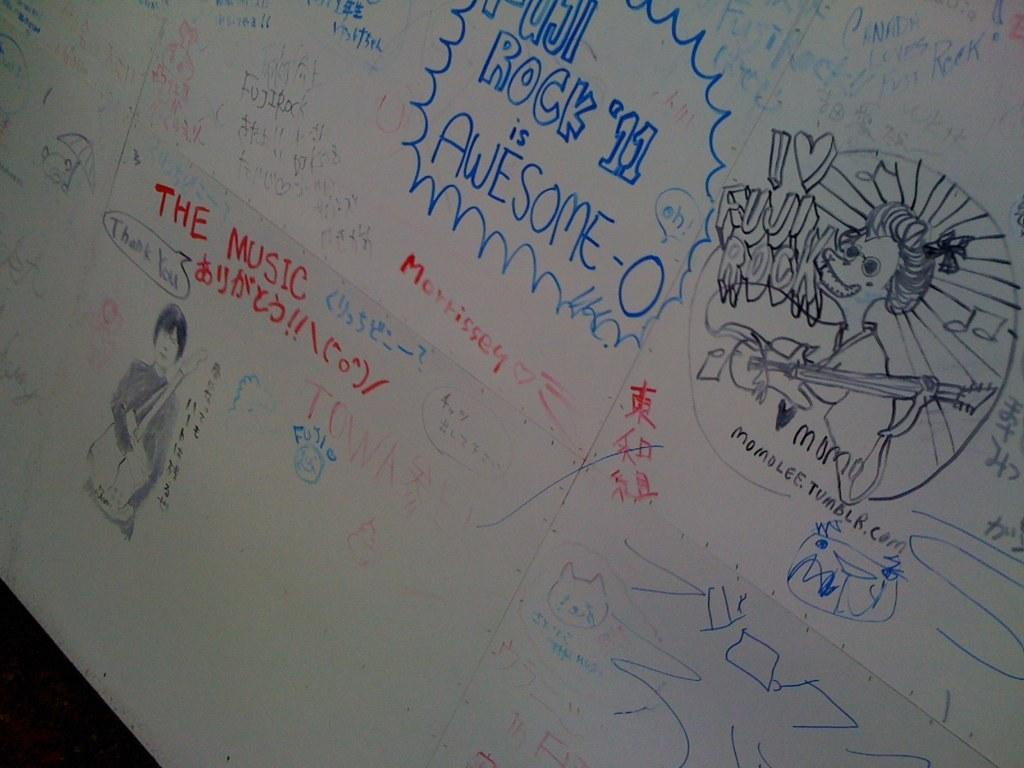Provide a one-sentence caption for the provided image. Whiteboard with a collection of drawings and words based on rock music. 